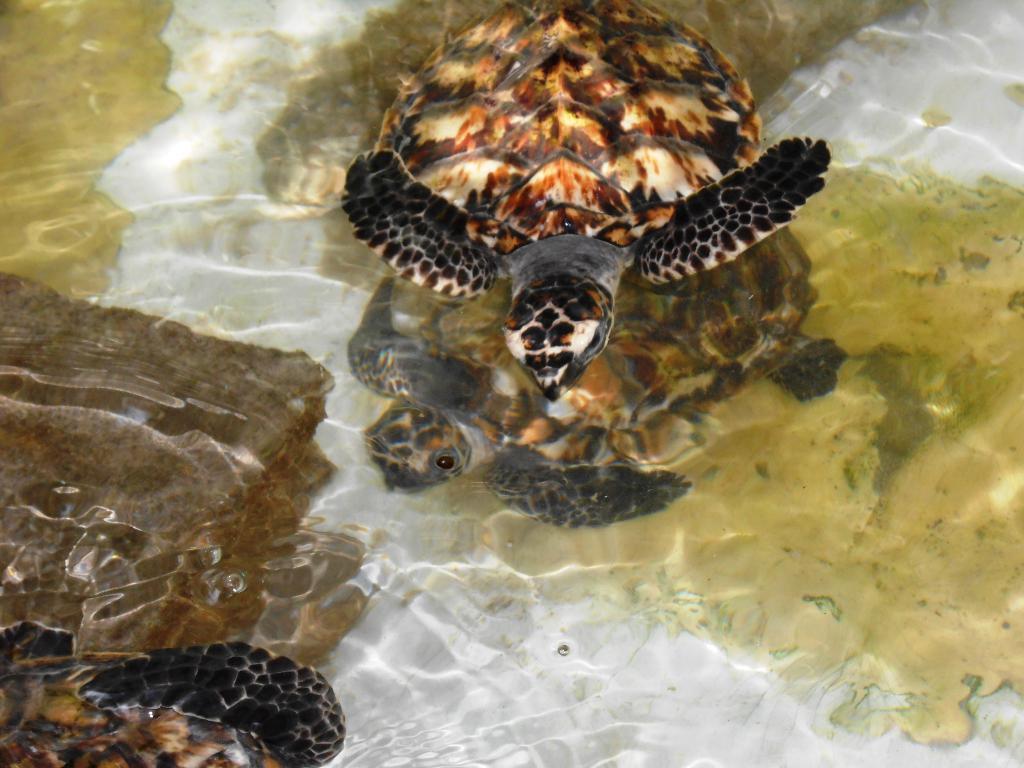Describe this image in one or two sentences. In this image, we can see some turtles. We can also see some water and the ground. 